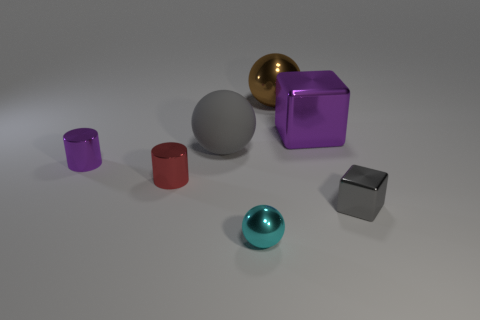Subtract all big brown balls. How many balls are left? 2 Add 2 large purple rubber cylinders. How many objects exist? 9 Subtract 1 gray balls. How many objects are left? 6 Subtract all spheres. How many objects are left? 4 Subtract all gray spheres. Subtract all brown cubes. How many spheres are left? 2 Subtract all big gray objects. Subtract all metallic cylinders. How many objects are left? 4 Add 3 large brown shiny spheres. How many large brown shiny spheres are left? 4 Add 1 tiny cyan metallic spheres. How many tiny cyan metallic spheres exist? 2 